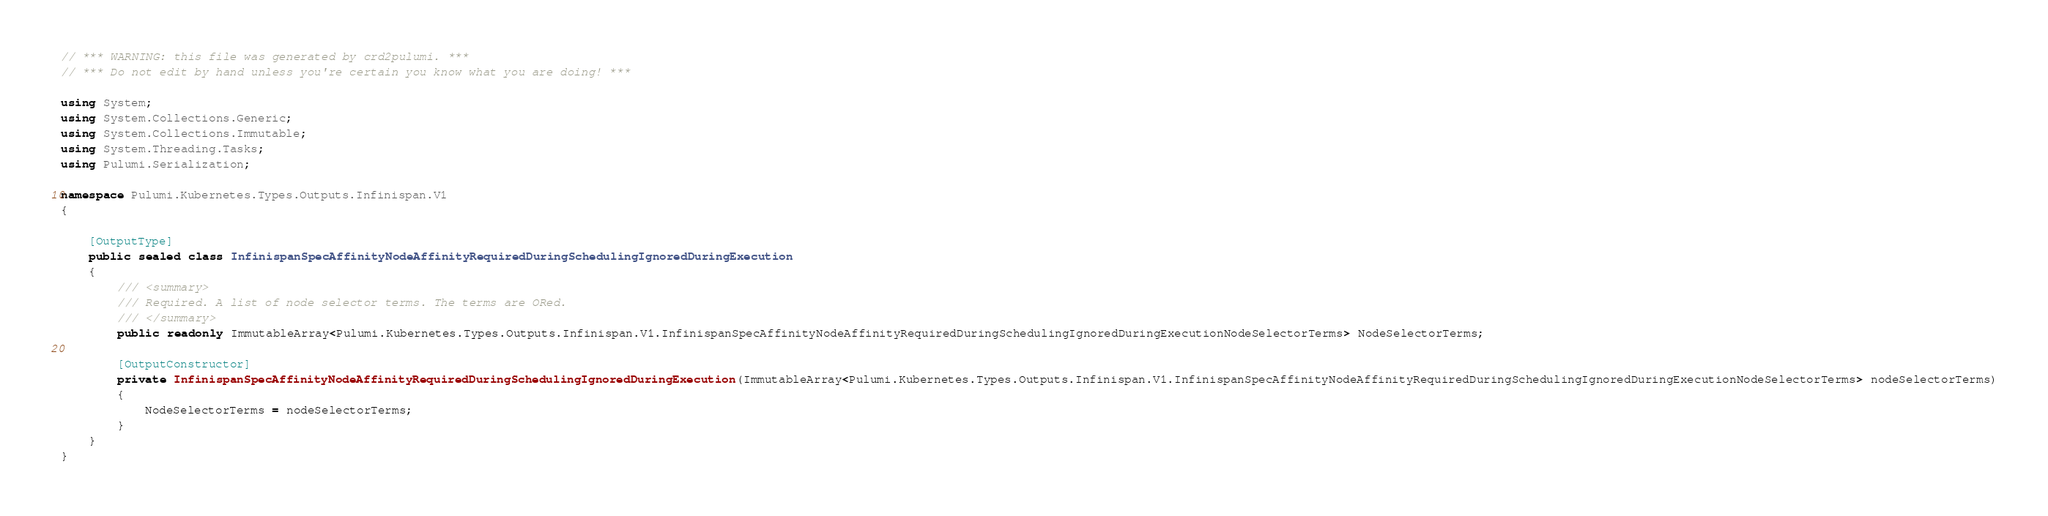<code> <loc_0><loc_0><loc_500><loc_500><_C#_>// *** WARNING: this file was generated by crd2pulumi. ***
// *** Do not edit by hand unless you're certain you know what you are doing! ***

using System;
using System.Collections.Generic;
using System.Collections.Immutable;
using System.Threading.Tasks;
using Pulumi.Serialization;

namespace Pulumi.Kubernetes.Types.Outputs.Infinispan.V1
{

    [OutputType]
    public sealed class InfinispanSpecAffinityNodeAffinityRequiredDuringSchedulingIgnoredDuringExecution
    {
        /// <summary>
        /// Required. A list of node selector terms. The terms are ORed.
        /// </summary>
        public readonly ImmutableArray<Pulumi.Kubernetes.Types.Outputs.Infinispan.V1.InfinispanSpecAffinityNodeAffinityRequiredDuringSchedulingIgnoredDuringExecutionNodeSelectorTerms> NodeSelectorTerms;

        [OutputConstructor]
        private InfinispanSpecAffinityNodeAffinityRequiredDuringSchedulingIgnoredDuringExecution(ImmutableArray<Pulumi.Kubernetes.Types.Outputs.Infinispan.V1.InfinispanSpecAffinityNodeAffinityRequiredDuringSchedulingIgnoredDuringExecutionNodeSelectorTerms> nodeSelectorTerms)
        {
            NodeSelectorTerms = nodeSelectorTerms;
        }
    }
}
</code> 